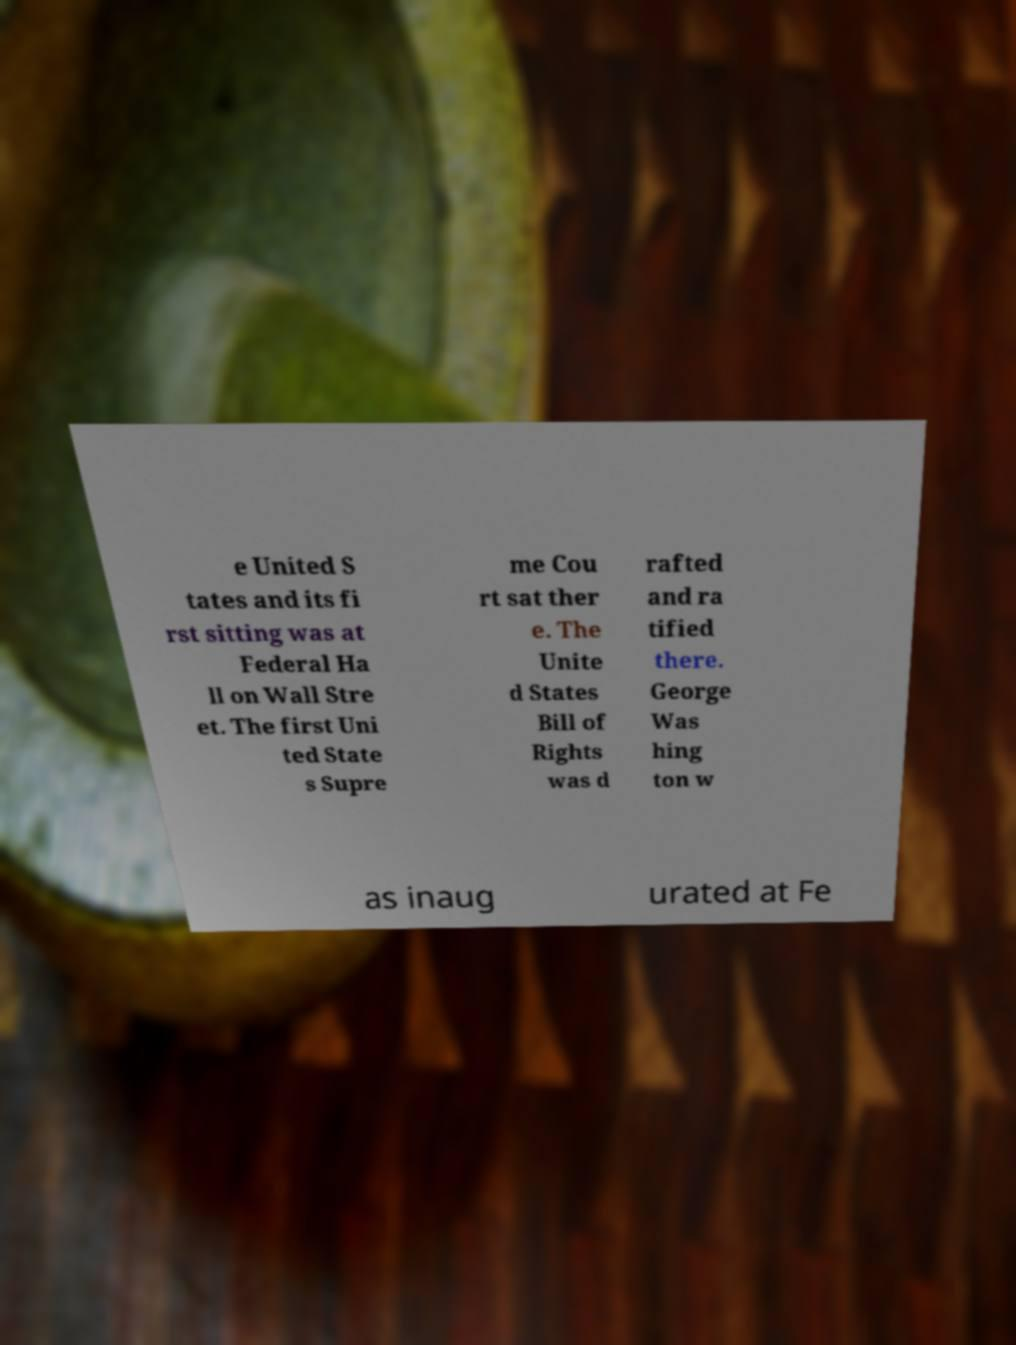I need the written content from this picture converted into text. Can you do that? e United S tates and its fi rst sitting was at Federal Ha ll on Wall Stre et. The first Uni ted State s Supre me Cou rt sat ther e. The Unite d States Bill of Rights was d rafted and ra tified there. George Was hing ton w as inaug urated at Fe 